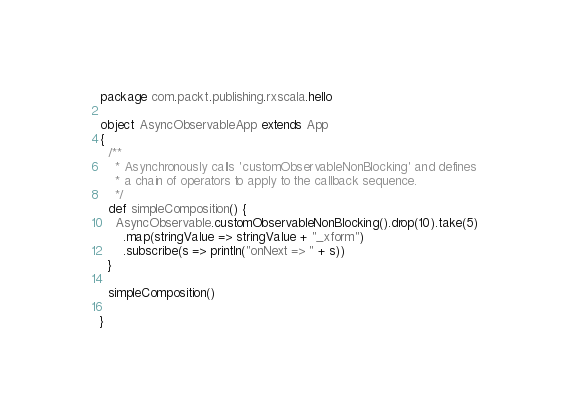<code> <loc_0><loc_0><loc_500><loc_500><_Scala_>package com.packt.publishing.rxscala.hello

object AsyncObservableApp extends App
{
  /**
    * Asynchronously calls 'customObservableNonBlocking' and defines
    * a chain of operators to apply to the callback sequence.
    */
  def simpleComposition() {
    AsyncObservable.customObservableNonBlocking().drop(10).take(5)
      .map(stringValue => stringValue + "_xform")
      .subscribe(s => println("onNext => " + s))
  }

  simpleComposition()

}</code> 